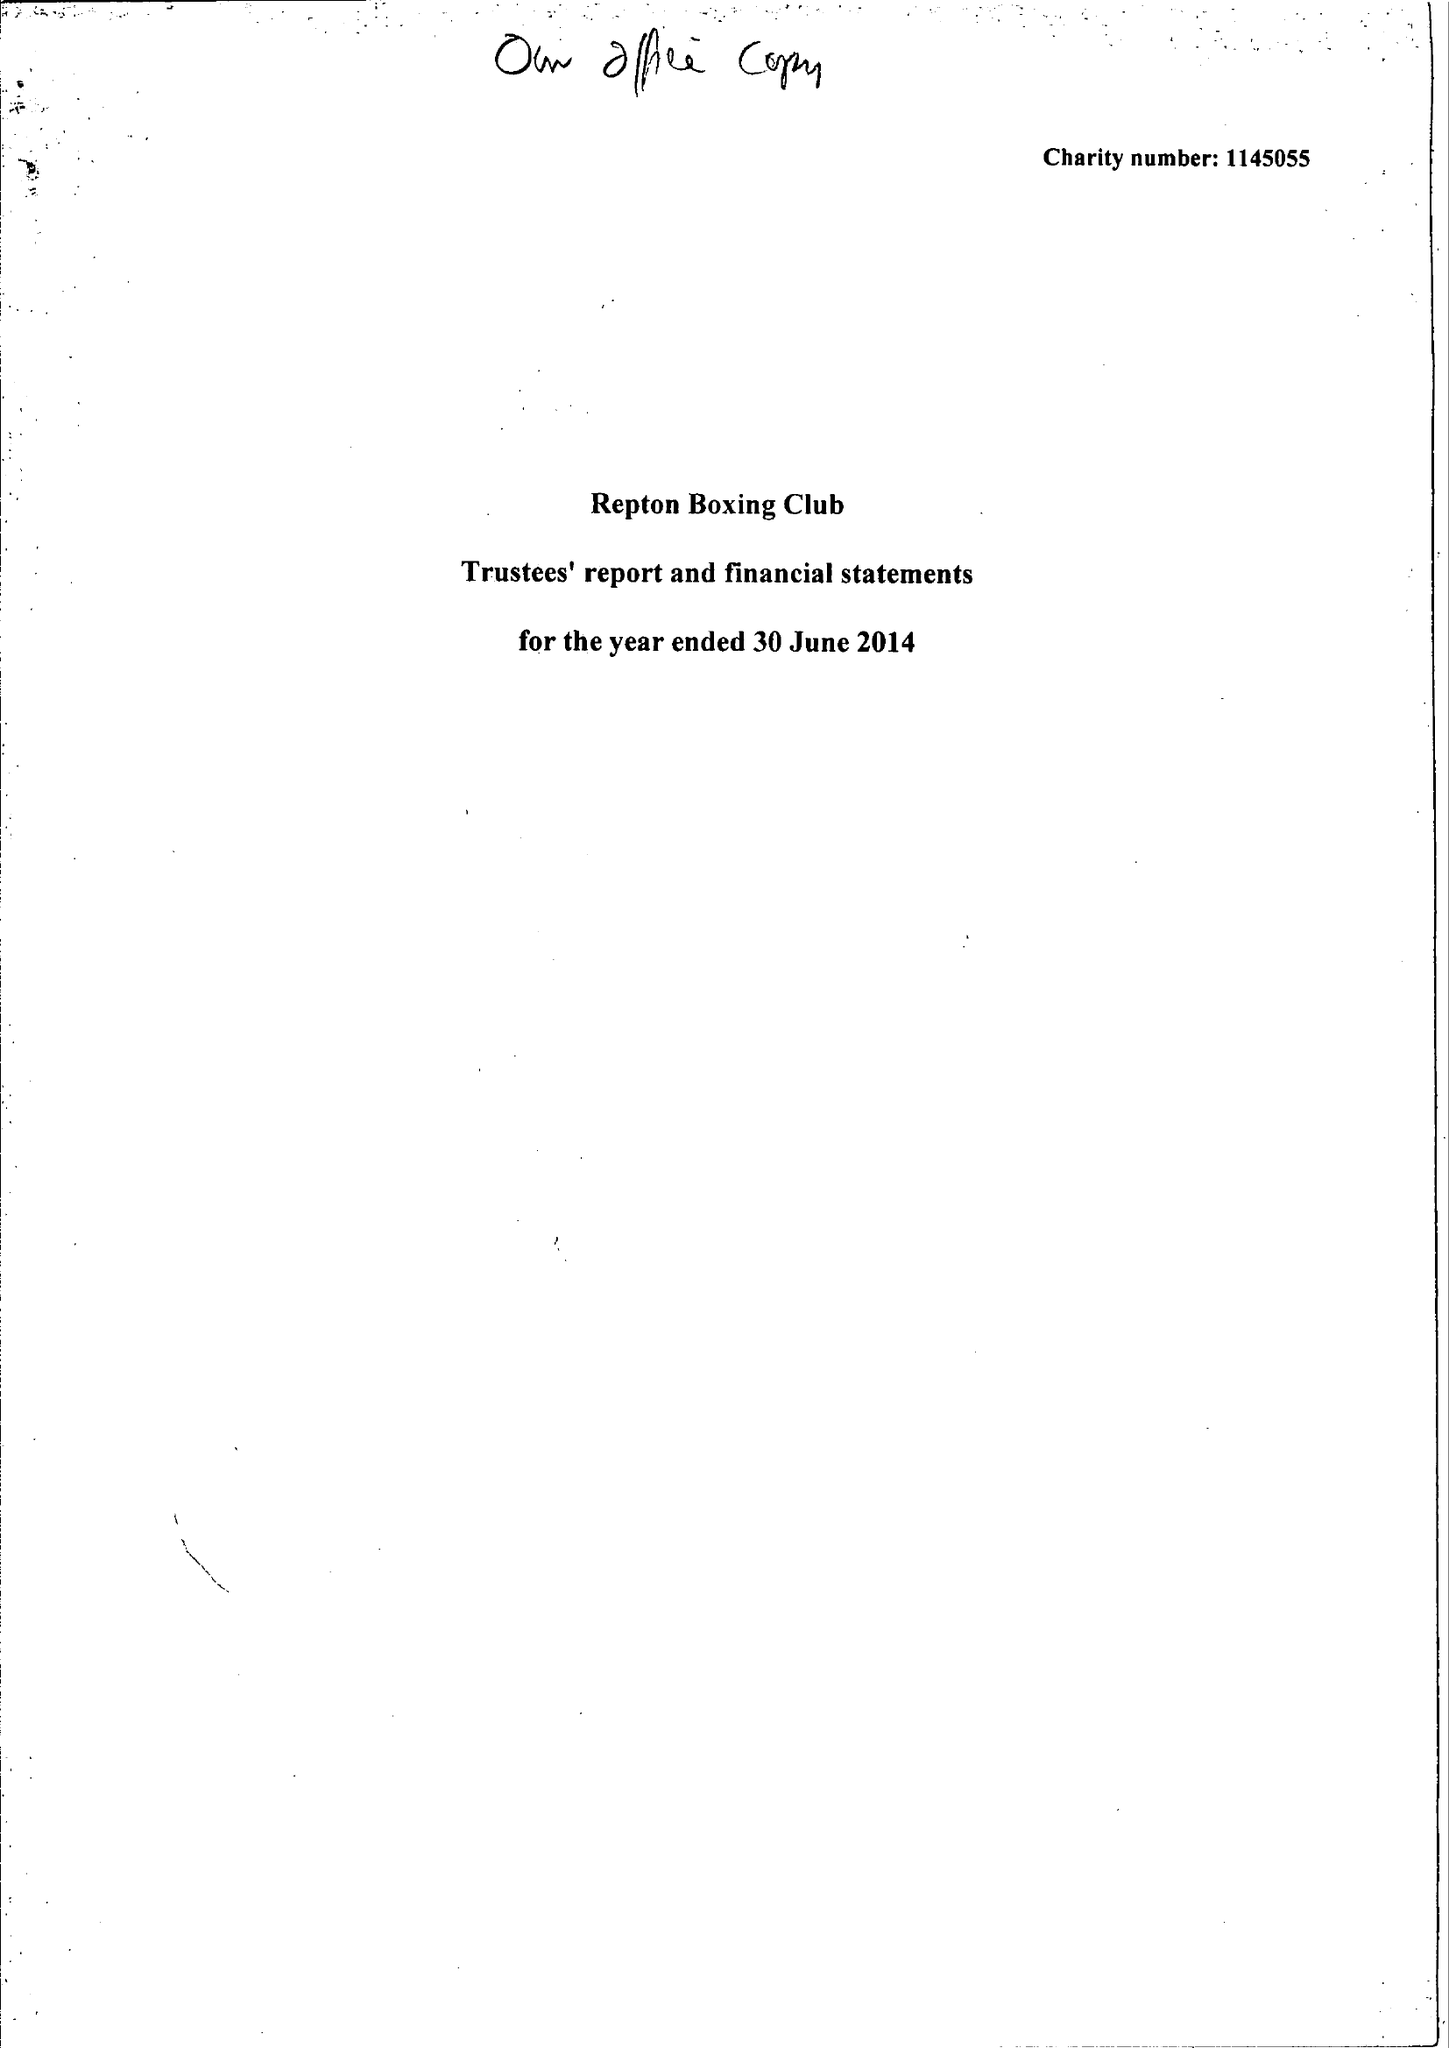What is the value for the spending_annually_in_british_pounds?
Answer the question using a single word or phrase. 44814.00 